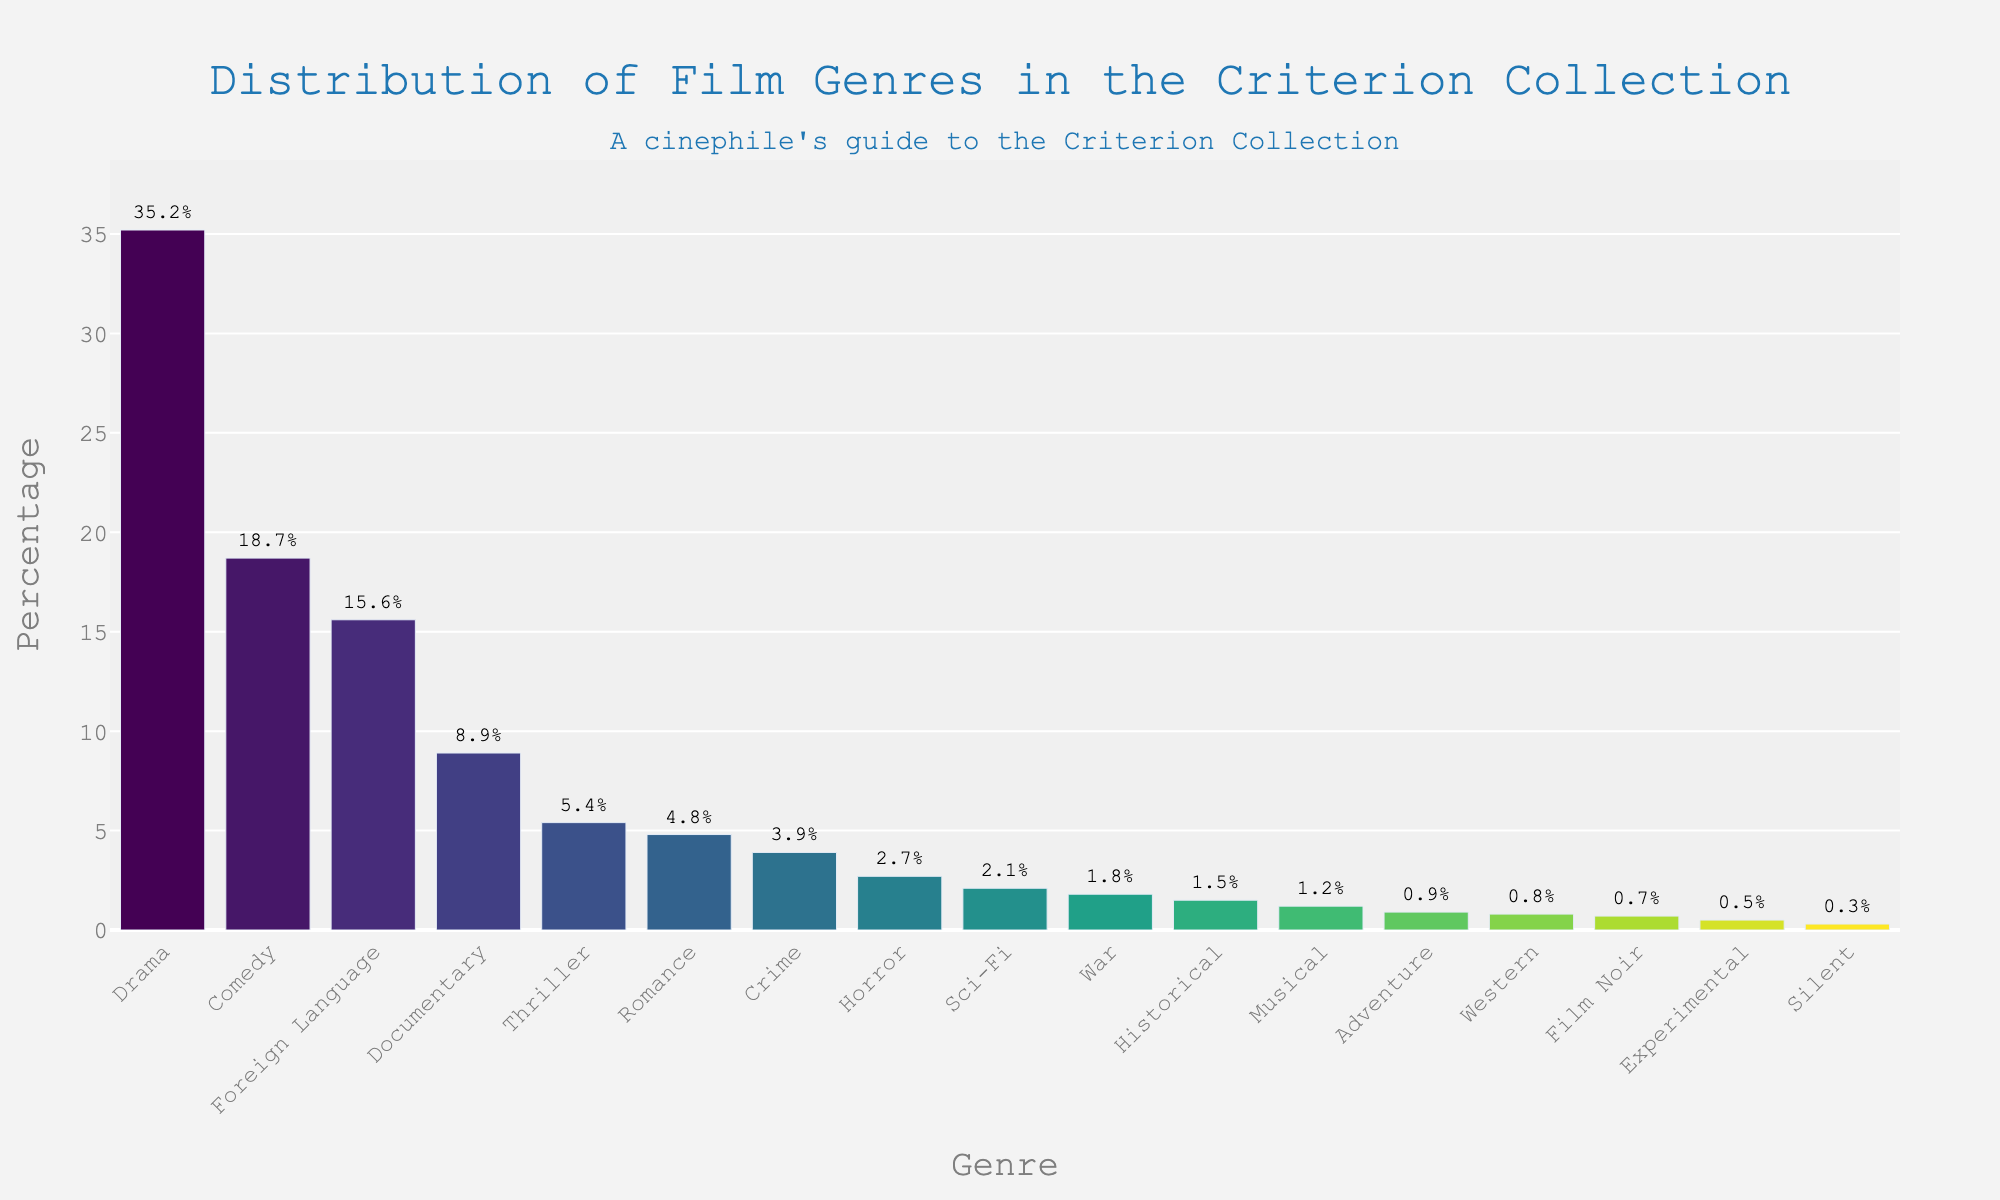What is the most common film genre in the Criterion Collection? The bar for Drama is the highest, indicating that it has the largest percentage among all genres.
Answer: Drama Which genre has a higher percentage, Horror or Sci-Fi? By comparing the bars visually, Horror has a percentage of 2.7%, while Sci-Fi has a percentage of 2.1%.
Answer: Horror What is the total percentage of Drama, Comedy, and Foreign Language films? The percentages for Drama, Comedy, and Foreign Language are 35.2%, 18.7%, and 15.6%. Adding these gives 35.2 + 18.7 + 15.6 = 69.5%.
Answer: 69.5% Which genres have a percentage less than 1%? From the bars on the chart, the genres with percentages less than 1% are Adventure, Western, Film Noir, Experimental, and Silent.
Answer: Adventure, Western, Film Noir, Experimental, Silent What is the combined percentage of Documentary, Thriller, and Romance genres compared to Drama? The percentages for Documentary, Thriller, and Romance are 8.9%, 5.4%, and 4.8%. Adding these gives 8.9 + 5.4 + 4.8 = 19.1%. Drama is 35.2%, which is greater than the combined 19.1%.
Answer: Drama > Documentary + Thriller + Romance Which genre takes up the smallest percentage in the Criterion Collection? The bar for Silent is the shortest, indicating it has the smallest percentage at 0.3%.
Answer: Silent If you group Crime, Horror, Sci-Fi, and Western together, what is their total percentage? The percentages for Crime, Horror, Sci-Fi, and Western are 3.9%, 2.7%, 2.1%, and 0.8%. Adding these gives 3.9 + 2.7 + 2.1 + 0.8 = 9.5%.
Answer: 9.5% How does the percentage of Foreign Language films compare to Documentary films? Foreign Language films have a percentage of 15.6%, and Documentary films have a percentage of 8.9%. Therefore, Foreign Language films have a higher percentage.
Answer: Foreign Language > Documentary Is the percentage of Adventure films more or less than 1%? The bar for Adventure films is just above the 1% mark, indicating that it is approximately 0.9%.
Answer: Less 